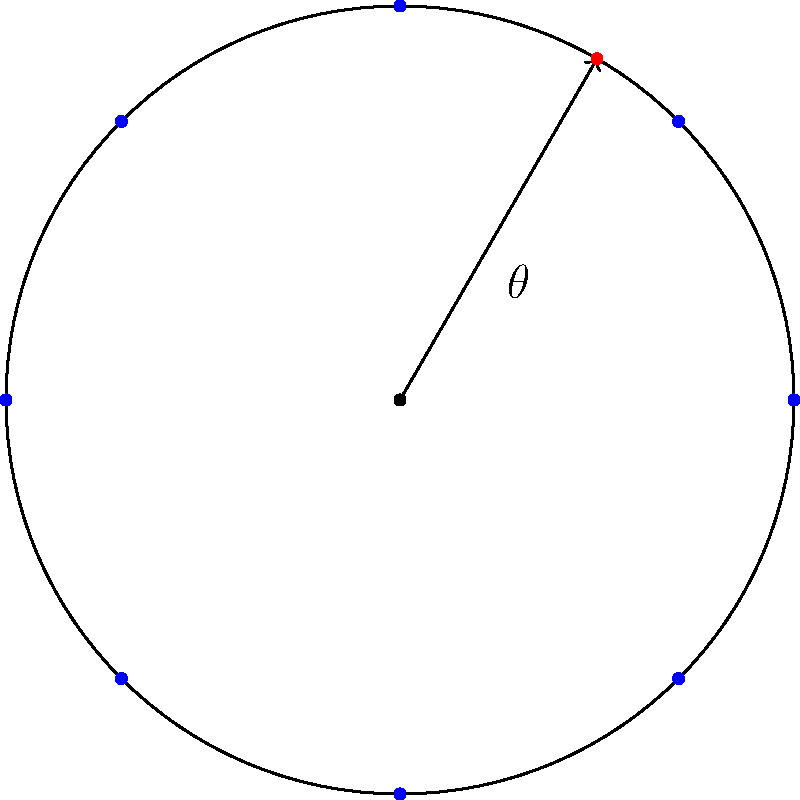In a circular array of 8 antennas equally spaced around the perimeter, a radio signal is detected with a phase difference of $\frac{\pi}{3}$ between adjacent antennas. Estimate the angle of arrival $\theta$ (in degrees) of the radio signal relative to the reference direction (positive x-axis). To solve this problem, we'll follow these steps:

1) In a circular array with $N$ antennas, the phase difference $\Delta\phi$ between adjacent elements for a signal arriving at angle $\theta$ is given by:

   $$\Delta\phi = \frac{2\pi d}{\lambda} \sin(\theta)$$

   where $d$ is the distance between adjacent antennas and $\lambda$ is the wavelength.

2) We're given that $\Delta\phi = \frac{\pi}{3}$ and $N = 8$.

3) For a circular array, $d = 2r\sin(\frac{\pi}{N})$, where $r$ is the radius of the circle.

4) Substituting this into our equation:

   $$\frac{\pi}{3} = \frac{2\pi (2r\sin(\frac{\pi}{8}))}{\lambda} \sin(\theta)$$

5) Simplifying:

   $$\frac{1}{6} = \frac{4r\sin(\frac{\pi}{8})}{\lambda} \sin(\theta)$$

6) We don't know $r$ or $\lambda$, but their ratio is often designed to be $\frac{r}{\lambda} = \frac{1}{4}$ for optimal performance. Using this:

   $$\frac{1}{6} = \sin(\frac{\pi}{8}) \sin(\theta)$$

7) Solving for $\theta$:

   $$\theta = \arcsin(\frac{1}{6\sin(\frac{\pi}{8})})$$

8) Calculating:

   $$\theta \approx 60.0°$$

Thus, the estimated angle of arrival is approximately 60 degrees.
Answer: 60° 